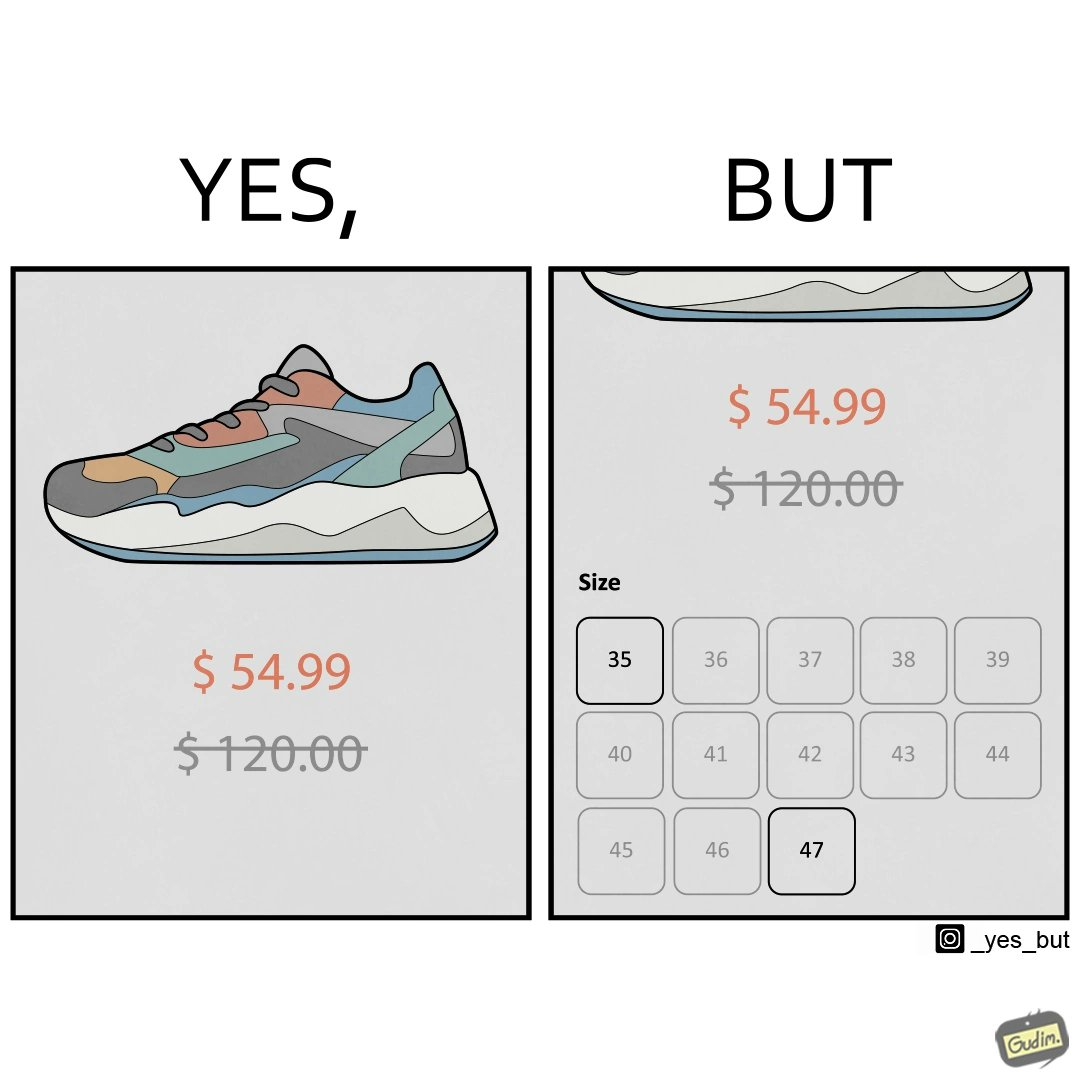Does this image contain satire or humor? Yes, this image is satirical. 